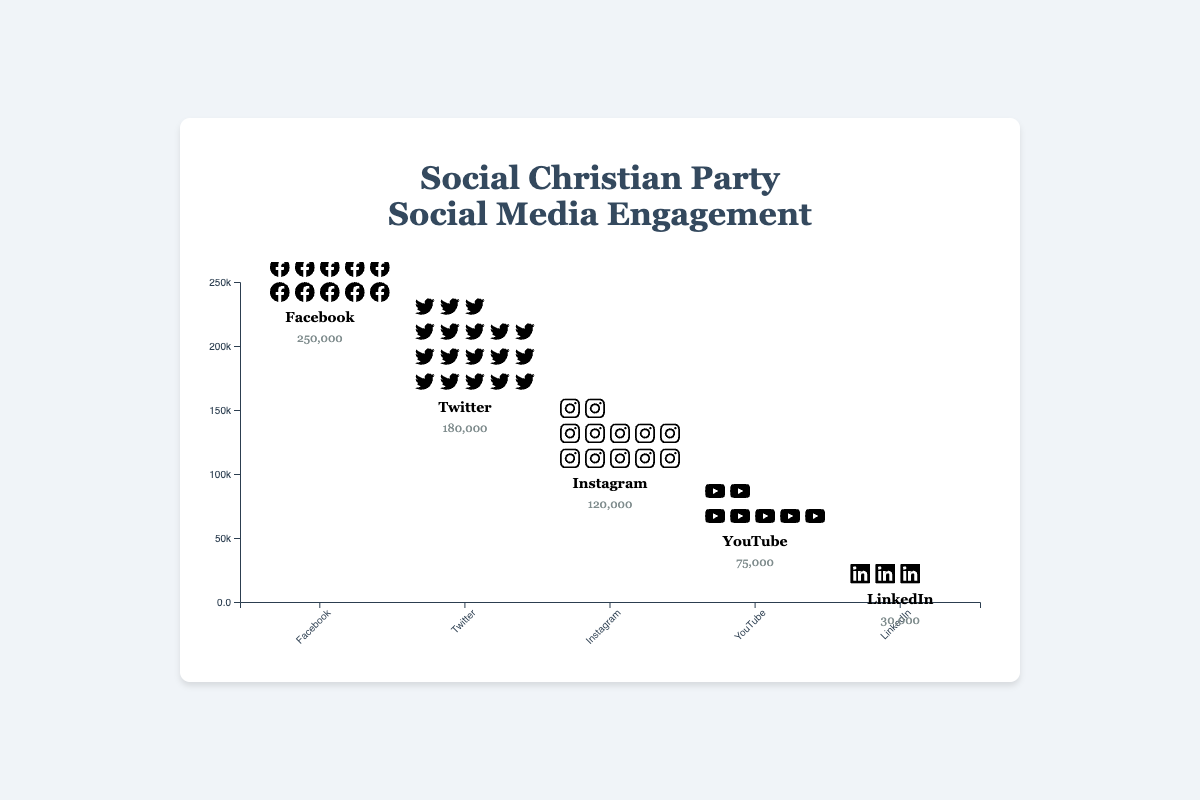Which platform has the highest social media engagement? By looking at the plot, we see that the tallest bar is for Facebook, indicating it has the highest number of engagements.
Answer: Facebook Which platform has the lowest engagements? The plot shows that LinkedIn's bar is the shortest, indicating the lowest number of engagements.
Answer: LinkedIn What is the total number of social media engagements across all platforms? Sum the engagements of all platforms: 250,000 (Facebook) + 180,000 (Twitter) + 120,000 (Instagram) + 75,000 (YouTube) + 30,000 (LinkedIn) = 655,000
Answer: 655,000 How much more engagement does Facebook have compared to Twitter? Subtract Twitter's engagements from Facebook's engagements: 250,000 - 180,000 = 70,000
Answer: 70,000 Which two platforms together have engagements closest to 200,000? Sum up engagements of possible pairs: Twitter (180,000) + LinkedIn (30,000) = 210,000; Instagram (120,000) + YouTube (75,000) = 195,000. The pair Instagram and YouTube is closest to 200,000 with 195,000 engagements.
Answer: Instagram and YouTube Which platform is in the middle in terms of engagements? When platforms are ordered by engagements, Instagram is third: Facebook (250,000), Twitter (180,000), Instagram (120,000), YouTube (75,000), LinkedIn (30,000).
Answer: Instagram How many icons represent each engagement level? Each icon represents 10,000 engagements. Divide engagements by 10,000 for each platform: Facebook (25 icons), Twitter (18 icons), Instagram (12 icons), YouTube (7.5 icons, rounded down to 7), LinkedIn (3 icons).
Answer: Varies by platform What is the percentage share of Facebook's engagements out of the total engagements? Calculate percentage: (250,000 / 655,000) * 100 ≈ 38.17%
Answer: 38.17% Which platform has about half the engagements of Facebook? Facebook has 250,000 engagements. Half of this is 125,000. Instagram, with 120,000 engagements, is closest to half of Facebook’s engagements.
Answer: Instagram How does YouTube's engagement compare to LinkedIn's engagement? YouTube has 75,000 engagements and LinkedIn has 30,000. YouTube has more engagements than LinkedIn.
Answer: YouTube has more 